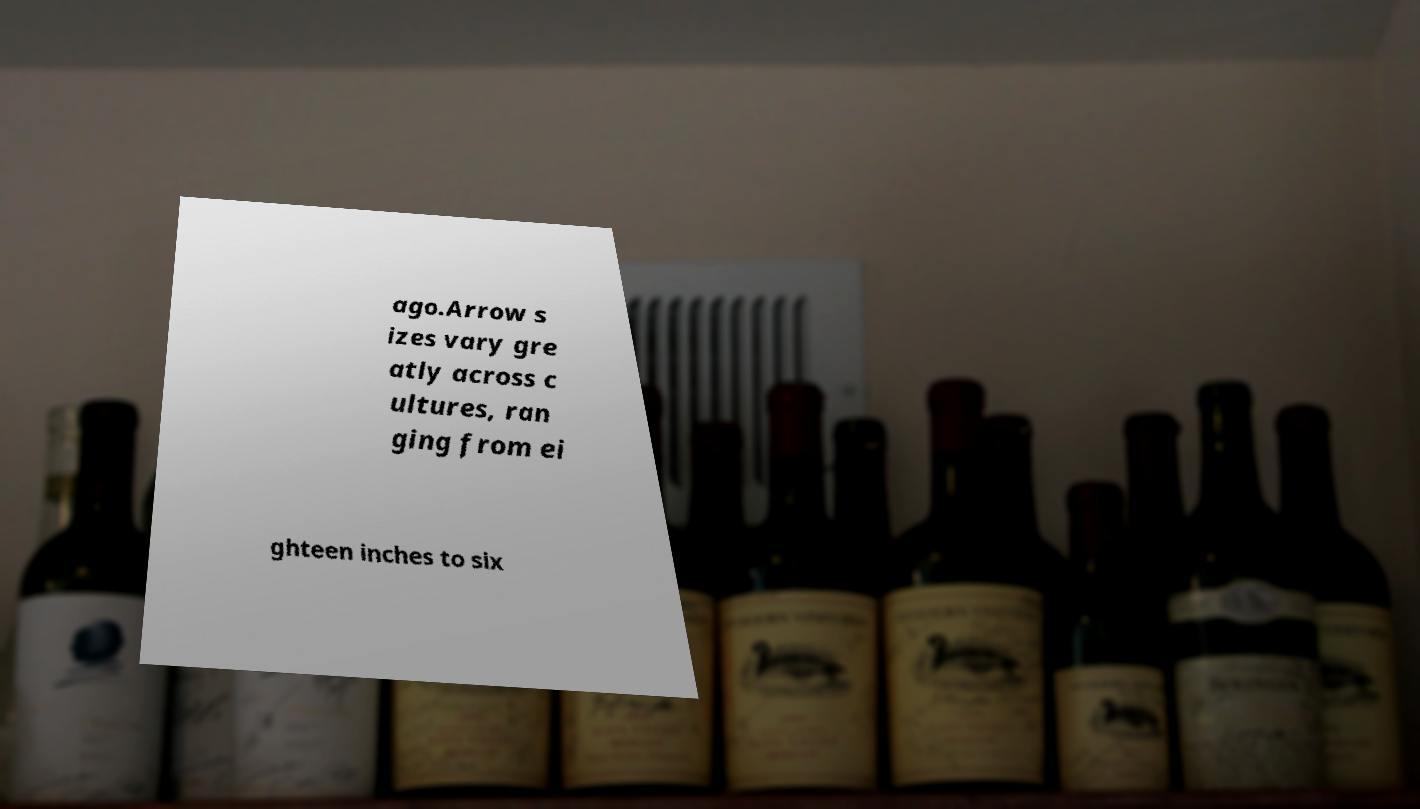Can you accurately transcribe the text from the provided image for me? ago.Arrow s izes vary gre atly across c ultures, ran ging from ei ghteen inches to six 